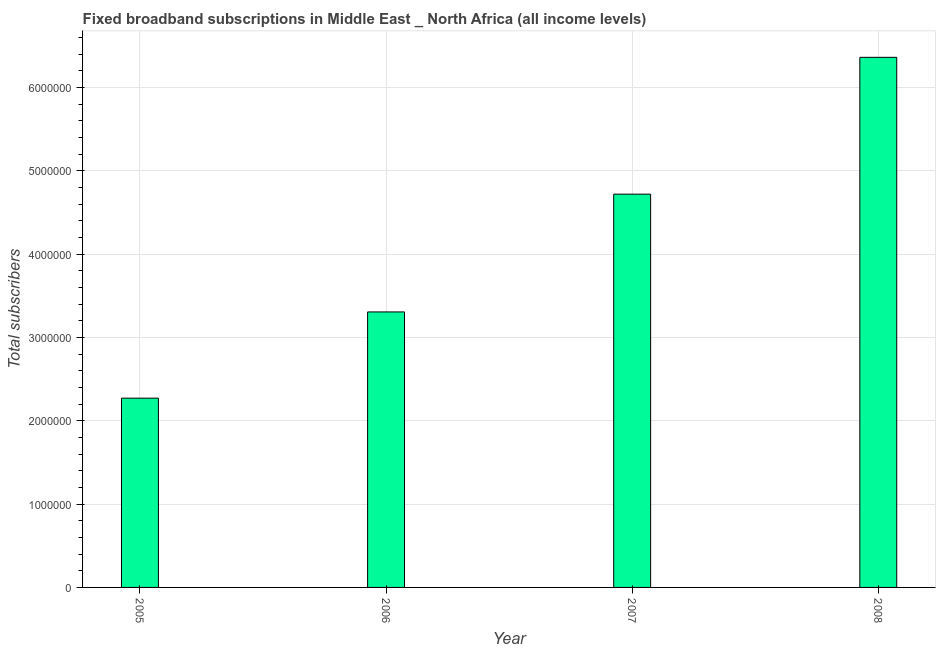Does the graph contain any zero values?
Provide a short and direct response. No. What is the title of the graph?
Your answer should be very brief. Fixed broadband subscriptions in Middle East _ North Africa (all income levels). What is the label or title of the X-axis?
Your answer should be very brief. Year. What is the label or title of the Y-axis?
Offer a very short reply. Total subscribers. What is the total number of fixed broadband subscriptions in 2007?
Provide a short and direct response. 4.72e+06. Across all years, what is the maximum total number of fixed broadband subscriptions?
Provide a succinct answer. 6.36e+06. Across all years, what is the minimum total number of fixed broadband subscriptions?
Provide a succinct answer. 2.27e+06. What is the sum of the total number of fixed broadband subscriptions?
Provide a succinct answer. 1.67e+07. What is the difference between the total number of fixed broadband subscriptions in 2006 and 2007?
Provide a succinct answer. -1.41e+06. What is the average total number of fixed broadband subscriptions per year?
Your response must be concise. 4.16e+06. What is the median total number of fixed broadband subscriptions?
Your answer should be very brief. 4.01e+06. What is the ratio of the total number of fixed broadband subscriptions in 2006 to that in 2008?
Your response must be concise. 0.52. Is the difference between the total number of fixed broadband subscriptions in 2007 and 2008 greater than the difference between any two years?
Make the answer very short. No. What is the difference between the highest and the second highest total number of fixed broadband subscriptions?
Your response must be concise. 1.64e+06. Is the sum of the total number of fixed broadband subscriptions in 2005 and 2008 greater than the maximum total number of fixed broadband subscriptions across all years?
Make the answer very short. Yes. What is the difference between the highest and the lowest total number of fixed broadband subscriptions?
Keep it short and to the point. 4.09e+06. In how many years, is the total number of fixed broadband subscriptions greater than the average total number of fixed broadband subscriptions taken over all years?
Offer a terse response. 2. How many bars are there?
Make the answer very short. 4. How many years are there in the graph?
Offer a terse response. 4. What is the difference between two consecutive major ticks on the Y-axis?
Your response must be concise. 1.00e+06. Are the values on the major ticks of Y-axis written in scientific E-notation?
Give a very brief answer. No. What is the Total subscribers of 2005?
Provide a short and direct response. 2.27e+06. What is the Total subscribers in 2006?
Offer a terse response. 3.31e+06. What is the Total subscribers in 2007?
Your answer should be very brief. 4.72e+06. What is the Total subscribers in 2008?
Make the answer very short. 6.36e+06. What is the difference between the Total subscribers in 2005 and 2006?
Your response must be concise. -1.04e+06. What is the difference between the Total subscribers in 2005 and 2007?
Your answer should be very brief. -2.45e+06. What is the difference between the Total subscribers in 2005 and 2008?
Keep it short and to the point. -4.09e+06. What is the difference between the Total subscribers in 2006 and 2007?
Keep it short and to the point. -1.41e+06. What is the difference between the Total subscribers in 2006 and 2008?
Your response must be concise. -3.06e+06. What is the difference between the Total subscribers in 2007 and 2008?
Your response must be concise. -1.64e+06. What is the ratio of the Total subscribers in 2005 to that in 2006?
Keep it short and to the point. 0.69. What is the ratio of the Total subscribers in 2005 to that in 2007?
Provide a succinct answer. 0.48. What is the ratio of the Total subscribers in 2005 to that in 2008?
Give a very brief answer. 0.36. What is the ratio of the Total subscribers in 2006 to that in 2007?
Your answer should be very brief. 0.7. What is the ratio of the Total subscribers in 2006 to that in 2008?
Provide a succinct answer. 0.52. What is the ratio of the Total subscribers in 2007 to that in 2008?
Your answer should be very brief. 0.74. 